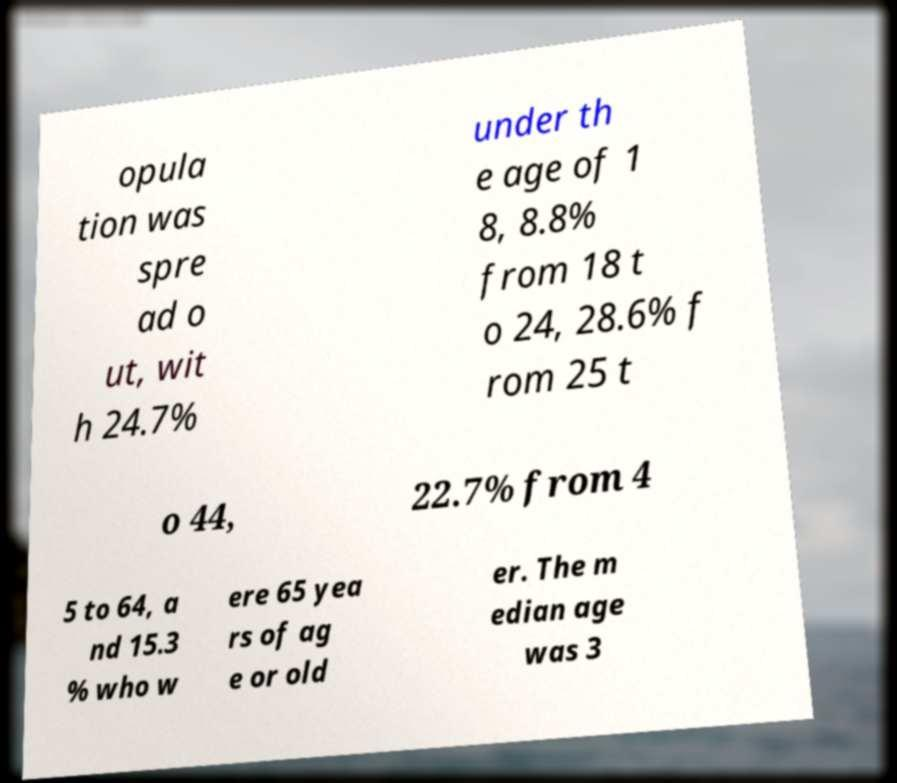I need the written content from this picture converted into text. Can you do that? opula tion was spre ad o ut, wit h 24.7% under th e age of 1 8, 8.8% from 18 t o 24, 28.6% f rom 25 t o 44, 22.7% from 4 5 to 64, a nd 15.3 % who w ere 65 yea rs of ag e or old er. The m edian age was 3 